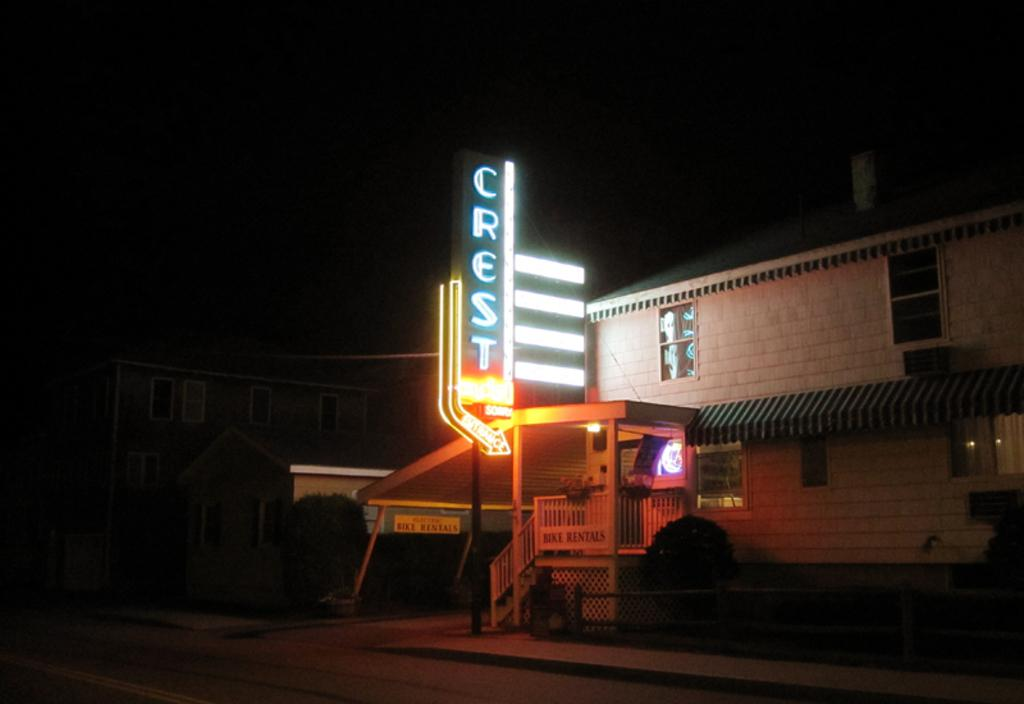What type of structures can be seen in the image? There are homes in the image. What additional feature is present in the image? There is a LED name board in the image. What type of locket is hanging from the LED name board in the image? There is no locket present in the image; it only features homes and a LED name board. 